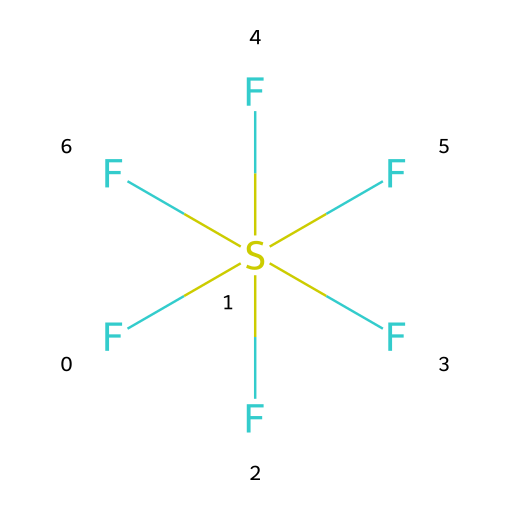What is the molecular formula of this compound? The SMILES notation indicates fluorine atoms (F) and one sulfur atom (S) in the molecular structure. Counting the number of fluorine atoms, we find there are six F atoms bonded to one S atom, leading to the molecular formula SF6.
Answer: SF6 How many total atoms are present in this molecule? The molecule consists of one sulfur atom and six fluorine atoms. By adding these together, we find a total of seven atoms in the entire structure.
Answer: 7 What type of chemical bond exists between sulfur and fluorine in this compound? The structure shows sulfur is centrally located with six fluorine atoms attached. These atoms are connected via single bonds, which are typical for this type of molecular structure.
Answer: single bond What is the geometry of sulfur hexafluoride? Sulfur hexafluoride has an octahedral geometry due to the arrangement of six surrounding fluorine atoms around the sulfur atom, leading to a symmetrical shape.
Answer: octahedral How does the presence of fluorine affect the properties of sulfur hexafluoride as a gas? Fluorine is highly electronegative, influencing the properties of sulfur hexafluoride to be non-toxic, stable, and a potent greenhouse gas due to its strong bonds and molecular weight.
Answer: non-toxic What makes sulfur hexafluoride a significant compound in industrial applications? The stability and inertness of SF6 make it ideal for use in electrical insulation and as a tracer gas in various research applications, showcasing its unique properties.
Answer: electrical insulation What is the primary industrial application of sulfur hexafluoride? The most common industrial application of SF6 is as an insulating gas in high-voltage electrical equipment, where it prevents electric discharges.
Answer: insulating gas 